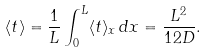<formula> <loc_0><loc_0><loc_500><loc_500>\langle t \rangle = \frac { 1 } { L } \int _ { 0 } ^ { L } \langle t \rangle _ { x } \, d x = \frac { L ^ { 2 } } { 1 2 D } .</formula> 